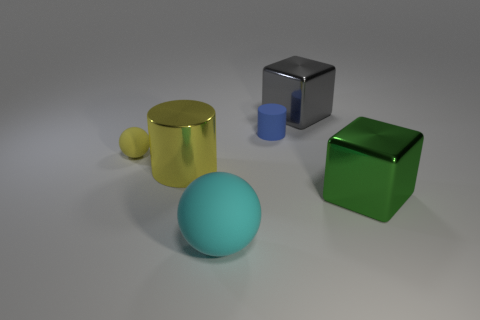Add 1 tiny green rubber blocks. How many objects exist? 7 Subtract all blocks. How many objects are left? 4 Subtract all small red matte blocks. Subtract all tiny yellow rubber objects. How many objects are left? 5 Add 6 shiny cylinders. How many shiny cylinders are left? 7 Add 4 blue cylinders. How many blue cylinders exist? 5 Subtract 1 cyan balls. How many objects are left? 5 